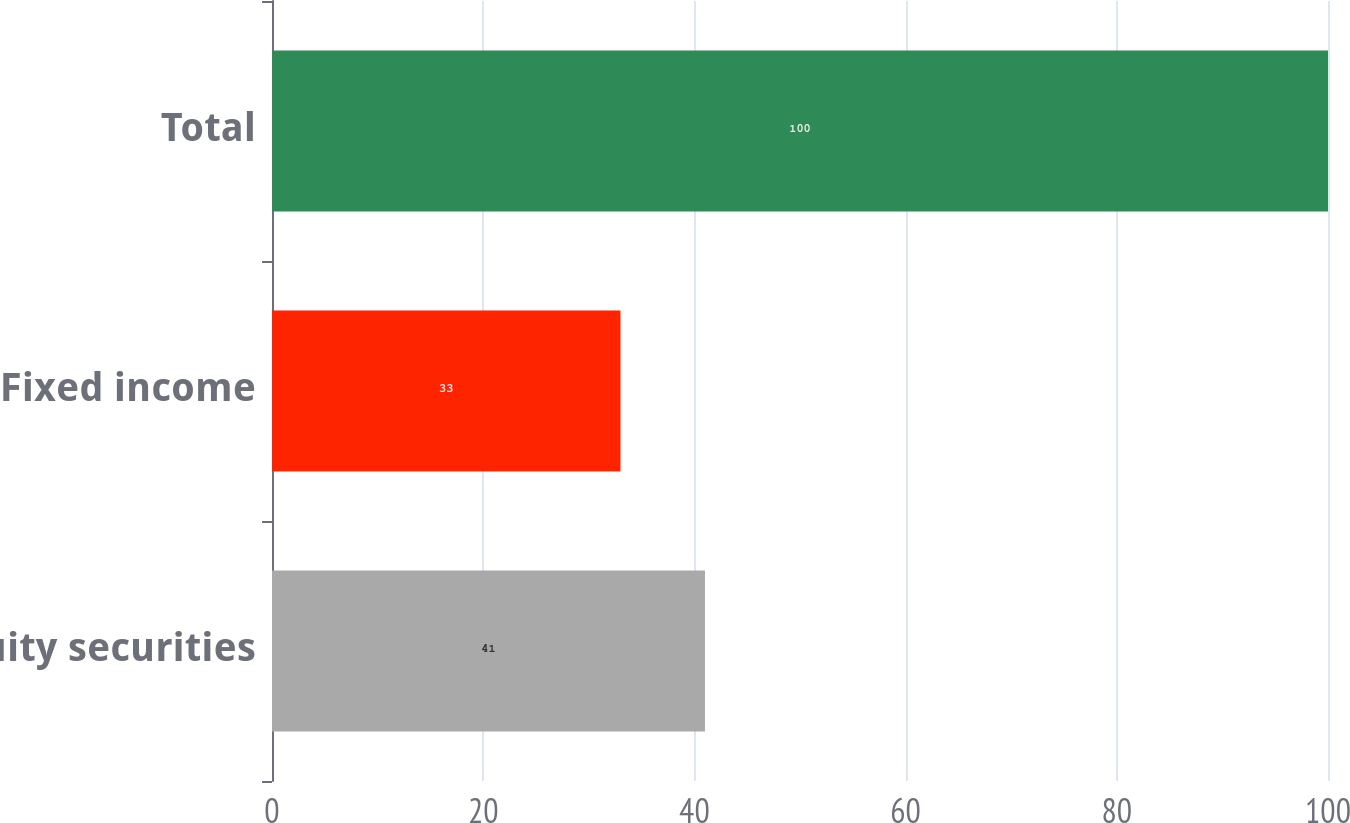Convert chart to OTSL. <chart><loc_0><loc_0><loc_500><loc_500><bar_chart><fcel>Equity securities<fcel>Fixed income<fcel>Total<nl><fcel>41<fcel>33<fcel>100<nl></chart> 